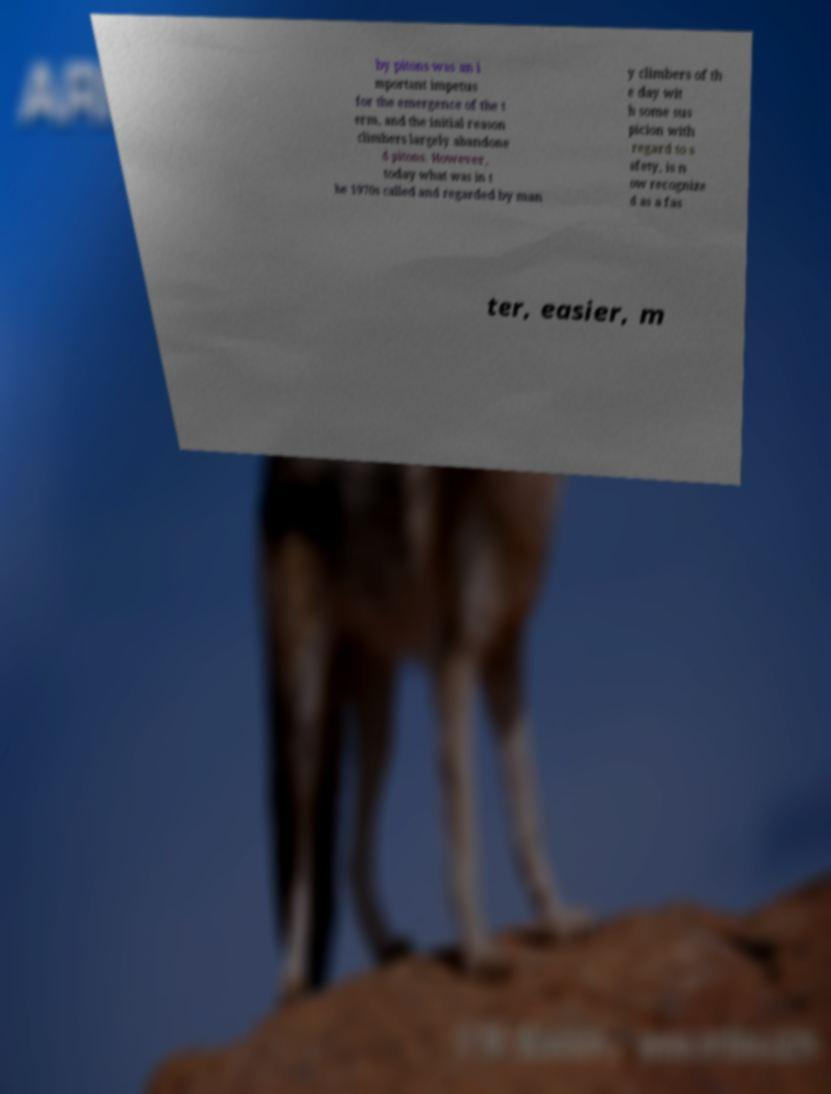Can you accurately transcribe the text from the provided image for me? by pitons was an i mportant impetus for the emergence of the t erm, and the initial reason climbers largely abandone d pitons. However, today what was in t he 1970s called and regarded by man y climbers of th e day wit h some sus picion with regard to s afety, is n ow recognize d as a fas ter, easier, m 